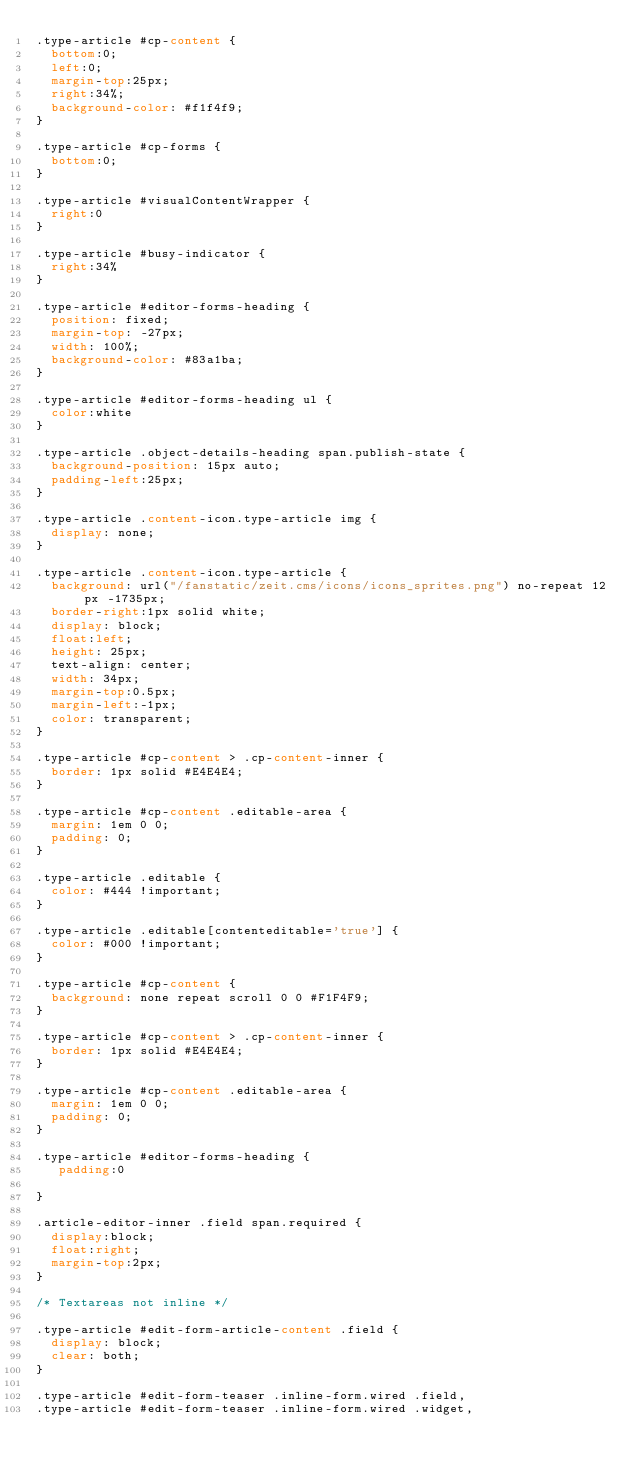<code> <loc_0><loc_0><loc_500><loc_500><_CSS_>.type-article #cp-content {
  bottom:0;
  left:0;
  margin-top:25px;
  right:34%;
  background-color: #f1f4f9;
}

.type-article #cp-forms {
  bottom:0;
}

.type-article #visualContentWrapper {
  right:0
}

.type-article #busy-indicator {
  right:34%
}

.type-article #editor-forms-heading {
  position: fixed;
  margin-top: -27px;
  width: 100%;
  background-color: #83a1ba;
}

.type-article #editor-forms-heading ul {
  color:white
}

.type-article .object-details-heading span.publish-state {
  background-position: 15px auto;
  padding-left:25px;
}

.type-article .content-icon.type-article img {
  display: none;
}

.type-article .content-icon.type-article {
  background: url("/fanstatic/zeit.cms/icons/icons_sprites.png") no-repeat 12px -1735px;
  border-right:1px solid white;
  display: block;
  float:left;
  height: 25px;
  text-align: center;
  width: 34px;
  margin-top:0.5px;
  margin-left:-1px;
  color: transparent;
}

.type-article #cp-content > .cp-content-inner {
  border: 1px solid #E4E4E4;
}

.type-article #cp-content .editable-area {
  margin: 1em 0 0;
  padding: 0;
}

.type-article .editable {
  color: #444 !important;
}

.type-article .editable[contenteditable='true'] {
  color: #000 !important;
}

.type-article #cp-content {
  background: none repeat scroll 0 0 #F1F4F9;
}

.type-article #cp-content > .cp-content-inner {
  border: 1px solid #E4E4E4;
}

.type-article #cp-content .editable-area {
  margin: 1em 0 0;
  padding: 0;
}

.type-article #editor-forms-heading {
   padding:0

}

.article-editor-inner .field span.required {
  display:block;
  float:right;
  margin-top:2px;
}

/* Textareas not inline */

.type-article #edit-form-article-content .field {
  display: block;
  clear: both;
}

.type-article #edit-form-teaser .inline-form.wired .field,
.type-article #edit-form-teaser .inline-form.wired .widget,</code> 